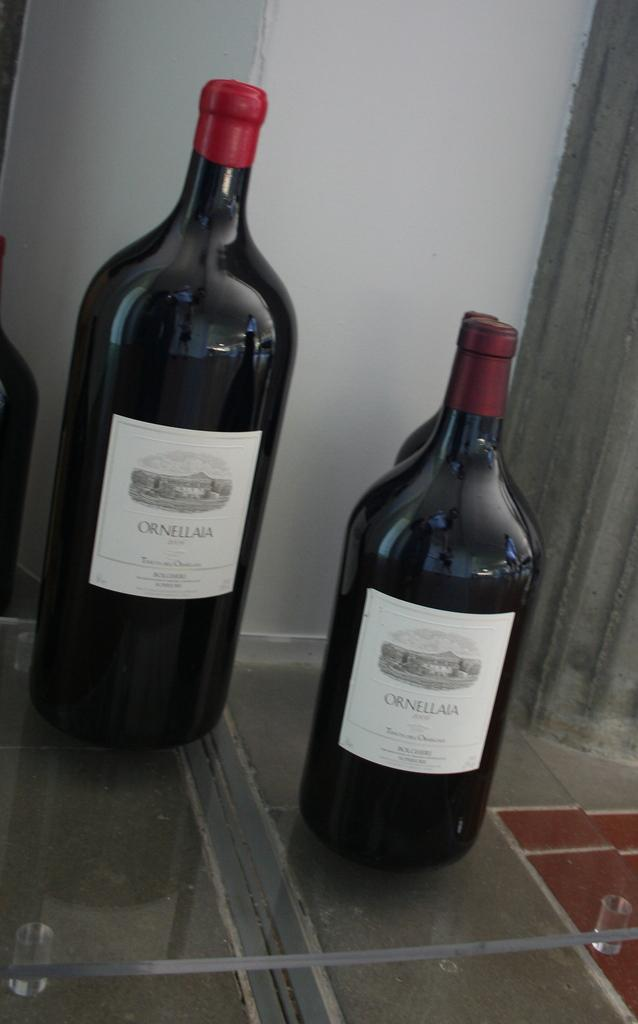<image>
Write a terse but informative summary of the picture. Two bottles or Ornellaia wine sit next to each other. 